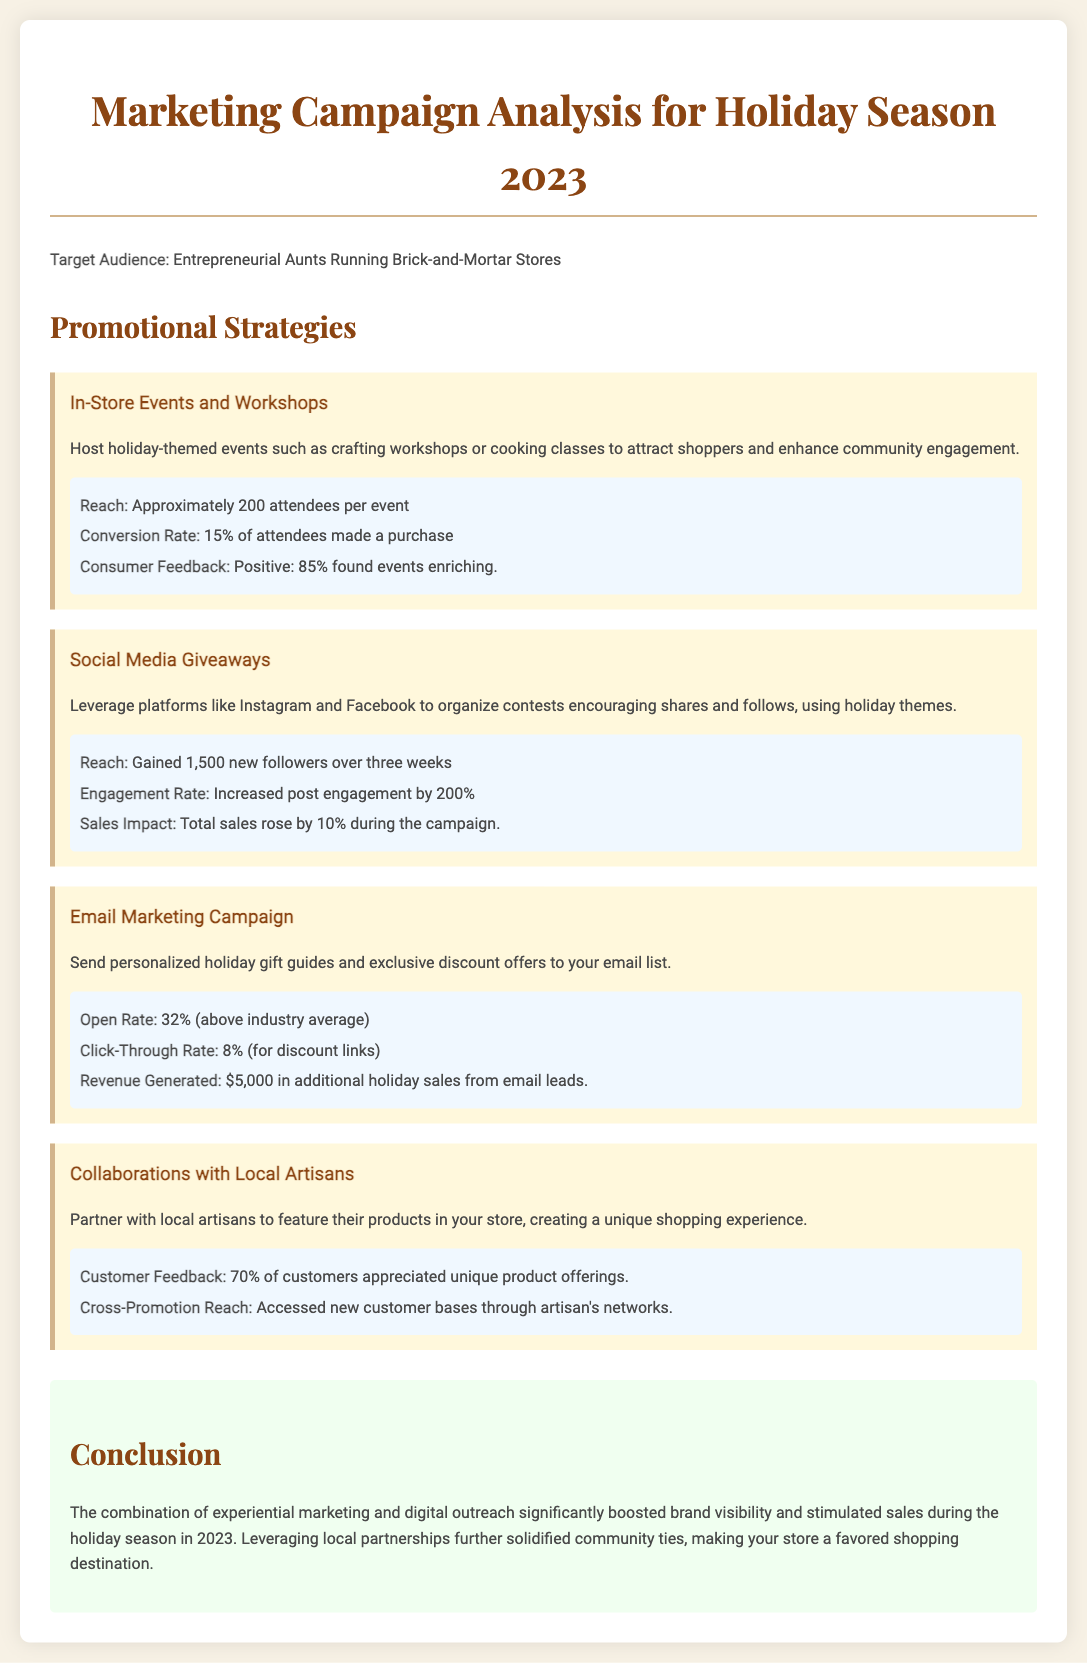What was the attendance for each event? The attendance for each event was approximately 200 attendees.
Answer: 200 attendees What was the engagement rate increase from the social media giveaways? The engagement rate increased by 200%.
Answer: 200% What was the click-through rate for the email marketing campaign? The click-through rate for the email marketing campaign was 8%.
Answer: 8% How much revenue did the email marketing campaign generate? The email marketing campaign generated $5,000 in additional holiday sales.
Answer: $5,000 What percentage of customers appreciated the unique product offerings from local artisans? 70% of customers appreciated the unique product offerings.
Answer: 70% Which promotional strategy had the highest impact on new followers? The social media giveaways gained 1,500 new followers.
Answer: 1,500 new followers What is the primary target audience mentioned? The primary target audience is entrepreneurial aunts running brick-and-mortar stores.
Answer: Entrepreneurial aunts running brick-and-mortar stores What was the conversion rate for in-store events? The conversion rate for in-store events was 15%.
Answer: 15% What type of events were suggested to enhance community engagement? Holiday-themed events such as crafting workshops or cooking classes were suggested.
Answer: Crafting workshops or cooking classes 